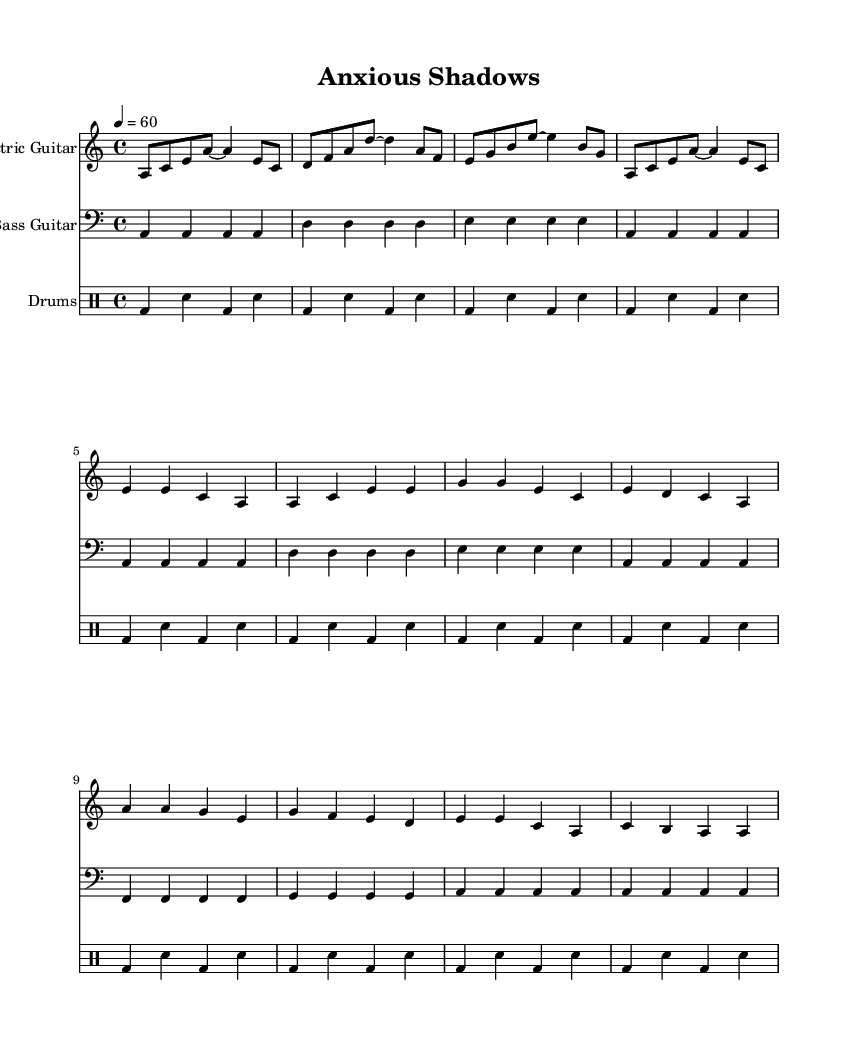What is the key signature of this music? The key signature is indicated at the beginning of the staff. The presence of no sharps or flats shows that it is in A minor.
Answer: A minor What is the time signature of this music? The time signature is shown at the beginning of the piece. The "4/4" notation indicates that there are four beats in each measure and the quarter note gets one beat.
Answer: 4/4 What is the tempo marking for this music? The tempo marking is found at the start of the music. The "4 = 60" indicates that there are 60 beats per minute, which is a slow tempo.
Answer: 60 How many measures are in the chorus section? To determine the number of measures in the chorus, we look at the specific section identified in the sheet music. The chorus has 4 measures.
Answer: 4 Which instrument has the lowest pitch range in this score? The bass guitar is written in the bass clef and typically plays at a lower pitch range compared to the electric guitar and drums, which are notated in higher ranges.
Answer: Bass Guitar What type of beat is primarily used in the drum part? The drum part primarily uses bass drum ('bd') and snare drum ('sn') hits repeatedly, creating a standard rhythmic structure typical in blues music.
Answer: Bass and snare What is a thematic focus of the electric blues represented in this sheet music? The thematic focus can be deduced from the introspective nature of the lyrics implied in the title "Anxious Shadows," indicating narratives about navigating social pressures.
Answer: Introspection 